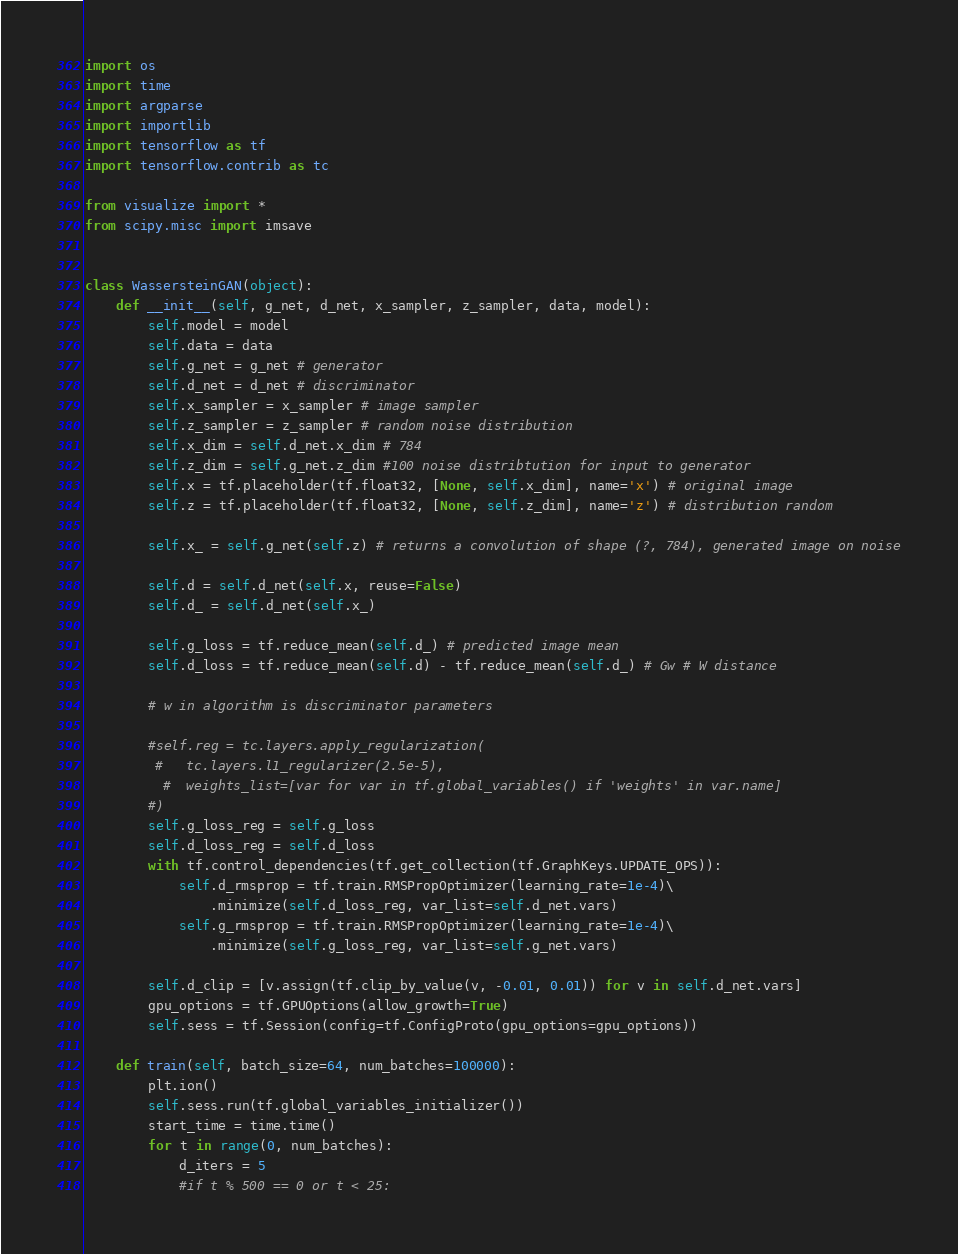Convert code to text. <code><loc_0><loc_0><loc_500><loc_500><_Python_>import os
import time
import argparse
import importlib
import tensorflow as tf
import tensorflow.contrib as tc

from visualize import *
from scipy.misc import imsave


class WassersteinGAN(object):
    def __init__(self, g_net, d_net, x_sampler, z_sampler, data, model):
        self.model = model
        self.data = data
        self.g_net = g_net # generator
        self.d_net = d_net # discriminator
        self.x_sampler = x_sampler # image sampler
        self.z_sampler = z_sampler # random noise distribution
        self.x_dim = self.d_net.x_dim # 784
        self.z_dim = self.g_net.z_dim #100 noise distribtution for input to generator
        self.x = tf.placeholder(tf.float32, [None, self.x_dim], name='x') # original image
        self.z = tf.placeholder(tf.float32, [None, self.z_dim], name='z') # distribution random

        self.x_ = self.g_net(self.z) # returns a convolution of shape (?, 784), generated image on noise

        self.d = self.d_net(self.x, reuse=False)
        self.d_ = self.d_net(self.x_)

        self.g_loss = tf.reduce_mean(self.d_) # predicted image mean
        self.d_loss = tf.reduce_mean(self.d) - tf.reduce_mean(self.d_) # Gw # W distance

        # w in algorithm is discriminator parameters

        #self.reg = tc.layers.apply_regularization(
         #   tc.layers.l1_regularizer(2.5e-5),
          #  weights_list=[var for var in tf.global_variables() if 'weights' in var.name]
        #)
        self.g_loss_reg = self.g_loss
        self.d_loss_reg = self.d_loss
        with tf.control_dependencies(tf.get_collection(tf.GraphKeys.UPDATE_OPS)):
            self.d_rmsprop = tf.train.RMSPropOptimizer(learning_rate=1e-4)\
                .minimize(self.d_loss_reg, var_list=self.d_net.vars)
            self.g_rmsprop = tf.train.RMSPropOptimizer(learning_rate=1e-4)\
                .minimize(self.g_loss_reg, var_list=self.g_net.vars)

        self.d_clip = [v.assign(tf.clip_by_value(v, -0.01, 0.01)) for v in self.d_net.vars]
        gpu_options = tf.GPUOptions(allow_growth=True)
        self.sess = tf.Session(config=tf.ConfigProto(gpu_options=gpu_options))

    def train(self, batch_size=64, num_batches=100000):
        plt.ion()
        self.sess.run(tf.global_variables_initializer())
        start_time = time.time()
        for t in range(0, num_batches):
            d_iters = 5
            #if t % 500 == 0 or t < 25:</code> 